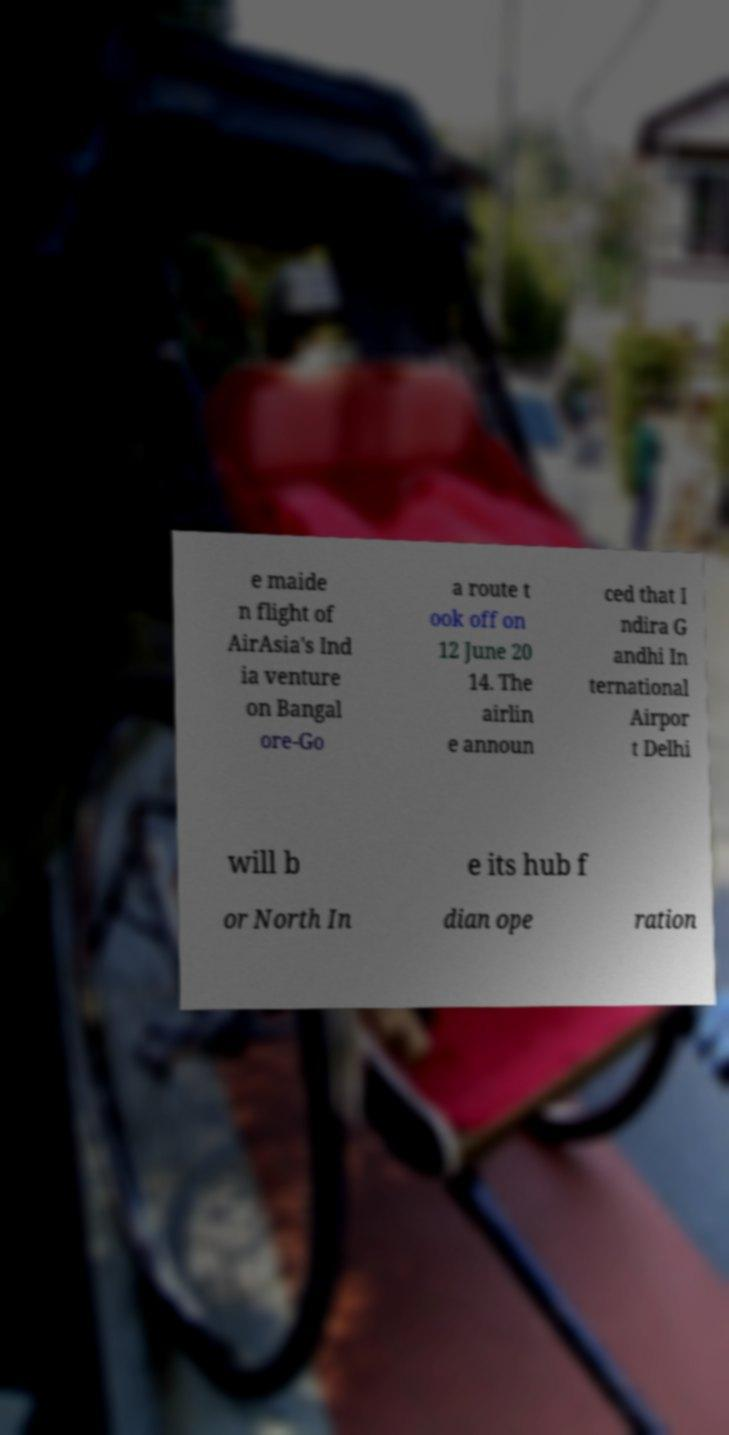Can you read and provide the text displayed in the image?This photo seems to have some interesting text. Can you extract and type it out for me? e maide n flight of AirAsia's Ind ia venture on Bangal ore-Go a route t ook off on 12 June 20 14. The airlin e announ ced that I ndira G andhi In ternational Airpor t Delhi will b e its hub f or North In dian ope ration 